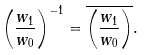Convert formula to latex. <formula><loc_0><loc_0><loc_500><loc_500>\left ( \frac { w _ { 1 } } { w _ { 0 } } \right ) ^ { - 1 } = \overline { \left ( \frac { w _ { 1 } } { w _ { 0 } } \right ) } .</formula> 